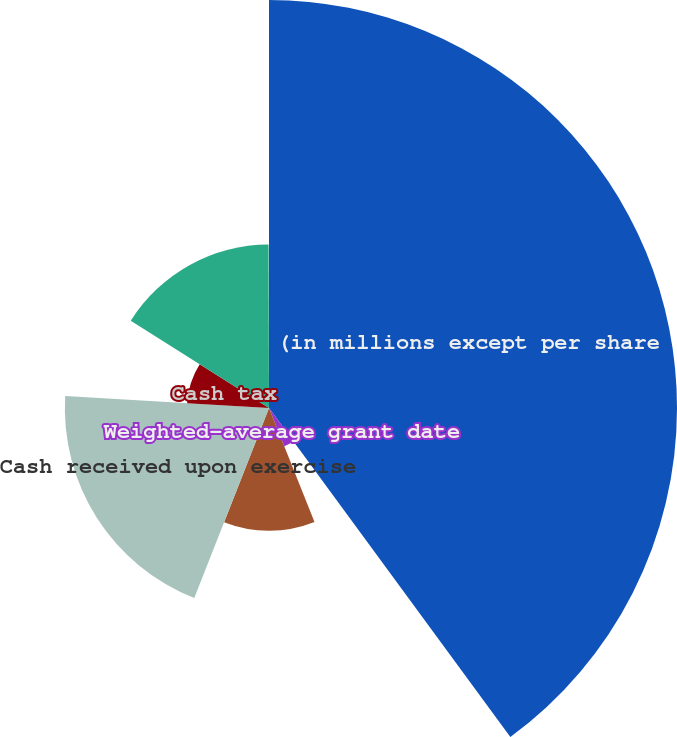<chart> <loc_0><loc_0><loc_500><loc_500><pie_chart><fcel>(in millions except per share<fcel>Weighted-average grant date<fcel>Aggregate intrinsic value of<fcel>Cash received upon exercise<fcel>Cash tax<fcel>Total compensation cost net of<fcel>Weighted-average periodin<nl><fcel>39.93%<fcel>4.03%<fcel>12.01%<fcel>19.98%<fcel>8.02%<fcel>16.0%<fcel>0.04%<nl></chart> 